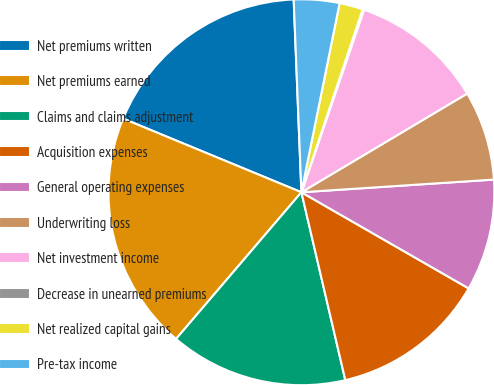Convert chart to OTSL. <chart><loc_0><loc_0><loc_500><loc_500><pie_chart><fcel>Net premiums written<fcel>Net premiums earned<fcel>Claims and claims adjustment<fcel>Acquisition expenses<fcel>General operating expenses<fcel>Underwriting loss<fcel>Net investment income<fcel>Decrease in unearned premiums<fcel>Net realized capital gains<fcel>Pre-tax income<nl><fcel>18.13%<fcel>19.98%<fcel>14.91%<fcel>13.04%<fcel>9.35%<fcel>7.5%<fcel>11.19%<fcel>0.12%<fcel>1.97%<fcel>3.81%<nl></chart> 